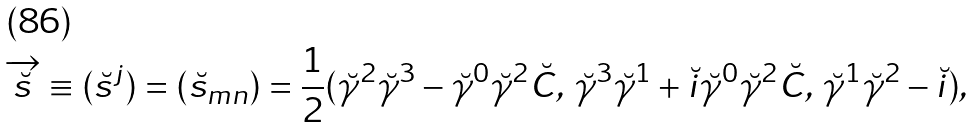<formula> <loc_0><loc_0><loc_500><loc_500>\overrightarrow { \breve { s } } \equiv ( \breve { s } ^ { j } ) = ( \breve { s } _ { m n } ) = \frac { 1 } { 2 } ( \breve { \gamma } ^ { 2 } \breve { \gamma } ^ { 3 } - \breve { \gamma } ^ { 0 } \breve { \gamma } ^ { 2 } \breve { C } , \, \breve { \gamma } ^ { 3 } \breve { \gamma } ^ { 1 } + \breve { i } \breve { \gamma } ^ { 0 } \breve { \gamma } ^ { 2 } \breve { C } , \, \breve { \gamma } ^ { 1 } \breve { \gamma } ^ { 2 } - \breve { i } ) ,</formula> 